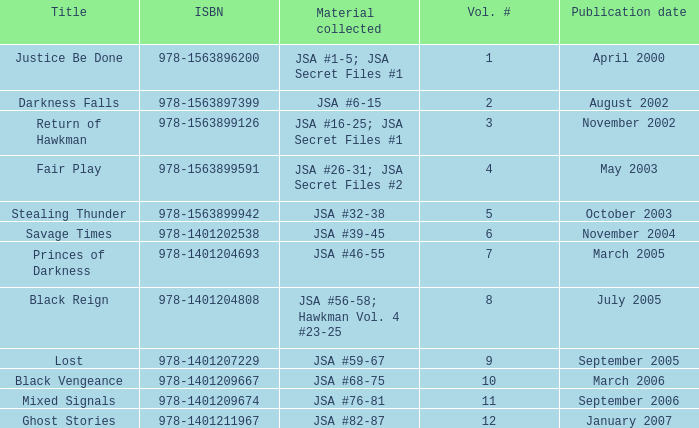What's the Material collected for the 978-1401209674 ISBN? JSA #76-81. 